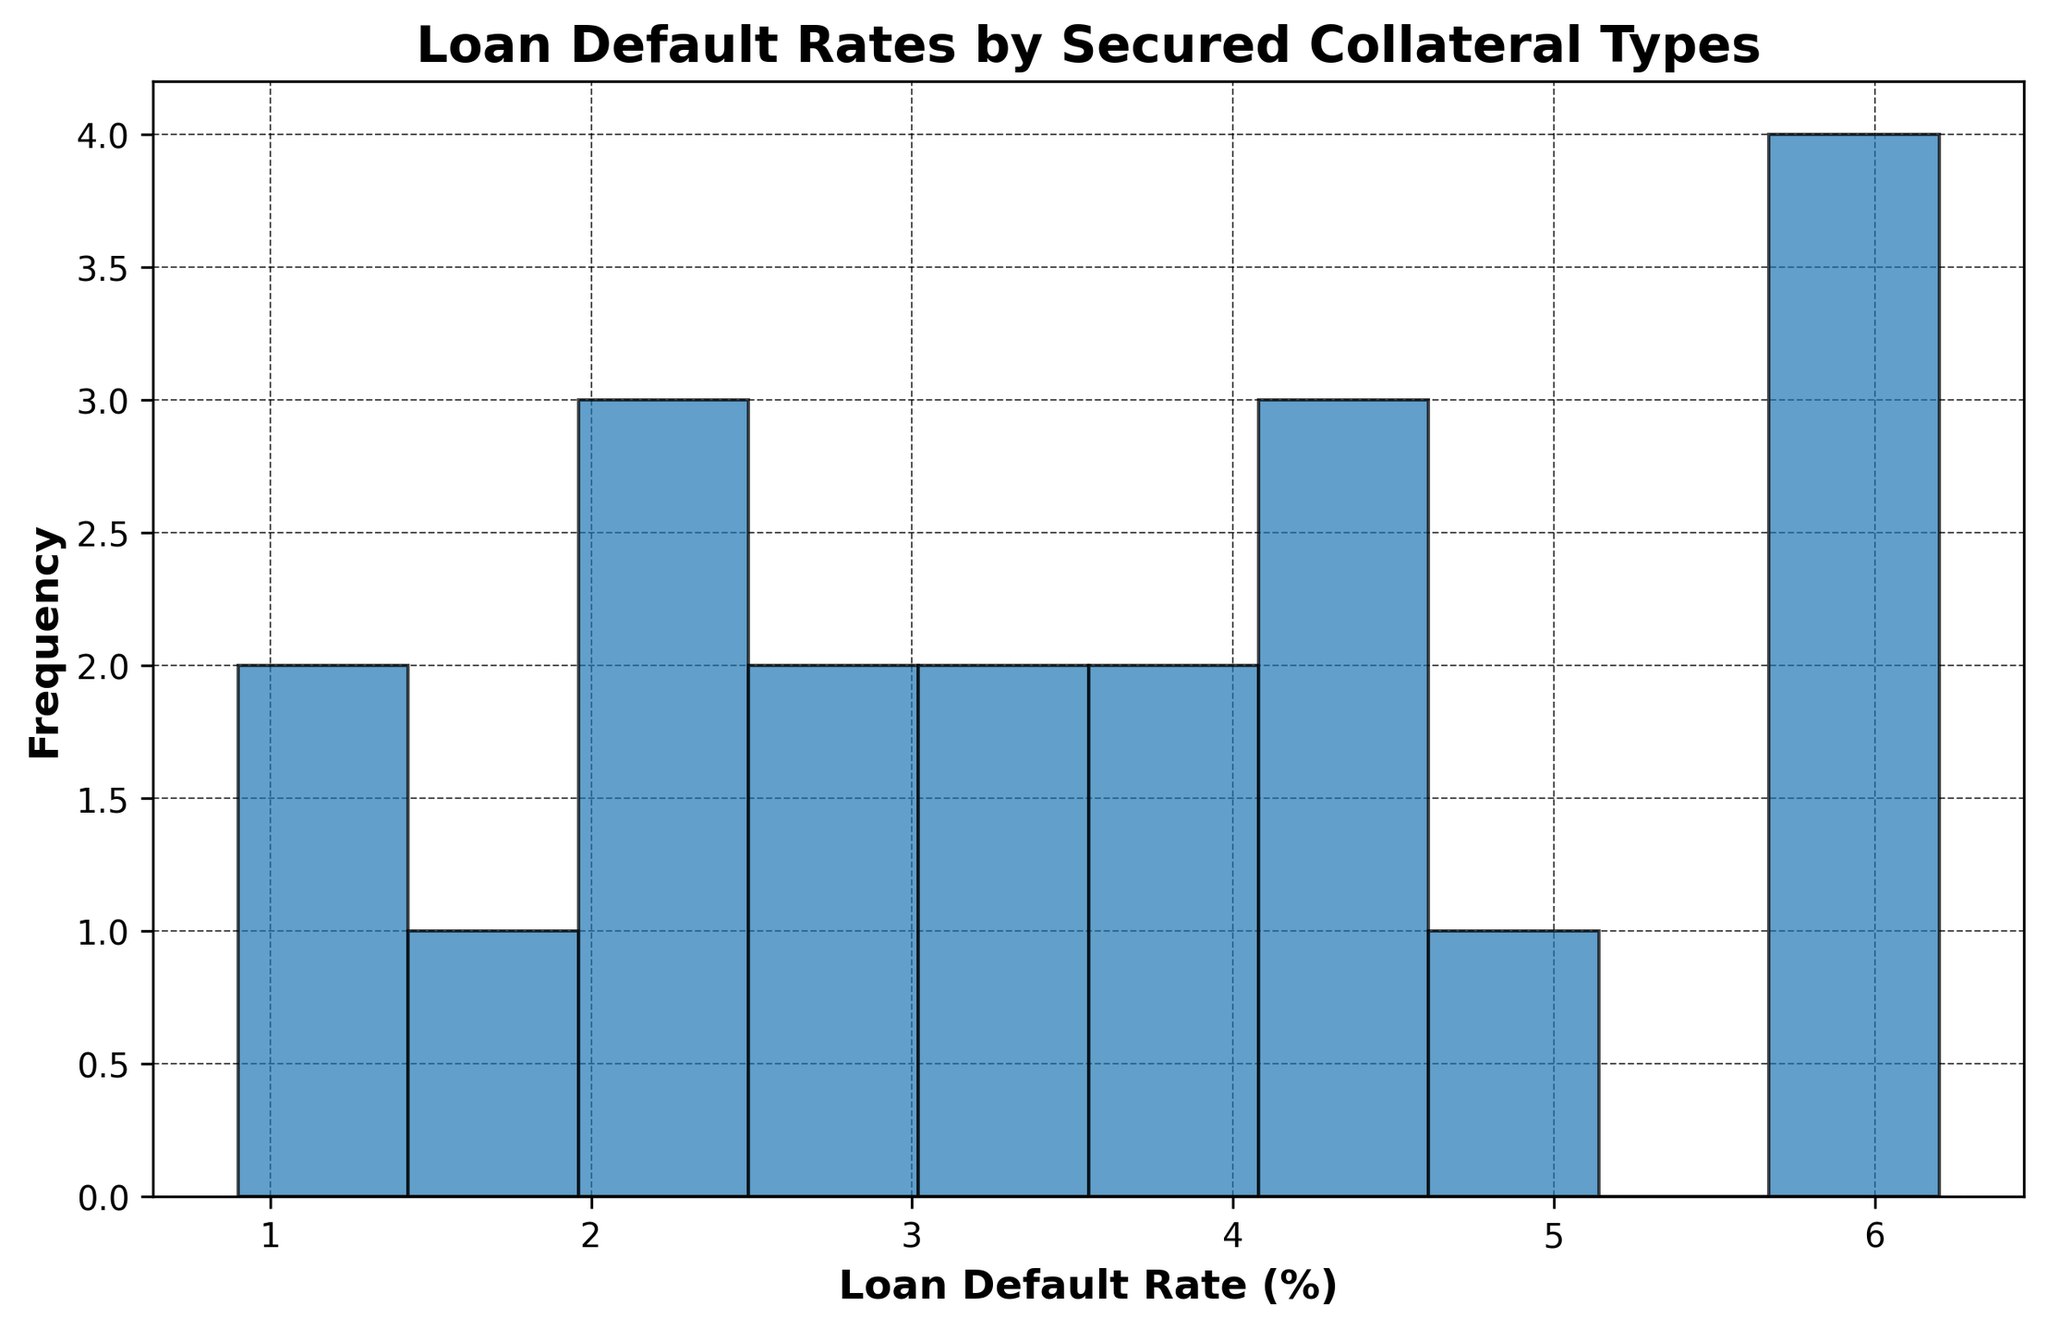Which collateral type has the highest loan default rate? By examining the histogram, we can identify the bar that reaches the farthest to the right, indicating the highest loan default rate.
Answer: Inventory What's the lowest loan default rate shown by the histogram? Look for the bar that reaches the least amount to the right, representing the lowest loan default rate.
Answer: Cash What is the average loan default rate for the collateral types? To find the average value, sum up all the loan default rates and divide by the number of types. [(2.5 + 4.1 + 3.3 + 5.7 + 6.2 + 1.8 + 0.9 + 4.8 + 3.6 + 2.1 + 2.7 + 4.4 + 3.1 + 6.1 + 5.9 + 2.0 + 1.1 + 4.5 + 3.7 + 2.3) / 20]
Answer: 3.55 How many collateral types have a loan default rate greater than 4%? Count the number of bars that extend beyond the 4% mark on the x-axis of the histogram.
Answer: 8 Compare the loan default rates of "Real Estate" and "Automobile". Which one is higher? By locating the bars for "Real Estate" and "Automobile" in the histogram, compare their heights to determine which is higher.
Answer: Automobile What's the range of loan default rates in the histogram? Identify the highest and lowest loan default rates, then calculate the difference. (6.2 - 0.9)
Answer: 5.3 Are there more collateral types with loan default rates below or above the average default rate? Calculate the average loan default rate and count the number of types below and above this average. (Count rates below 3.55 and those above 3.55)
Answer: Below What percentage of collateral types have a loan default rate of 3% or less? Count the number of bars with rates up to 3% and divide by the total number of types, then convert this to a percentage. (5 bars out of 20, so (5/20)*100)
Answer: 25% Is the most frequent loan default rate within the range of 4%-5%? Check the histogram to see if the tallest bar (highest frequency) falls within the specified range.
Answer: Yes Which type of loans tends to have the most secure collateral based on the lowest default rates? Identify the collateral type with the lowest default rate by examining the shortest bar in the histogram.
Answer: Cash 